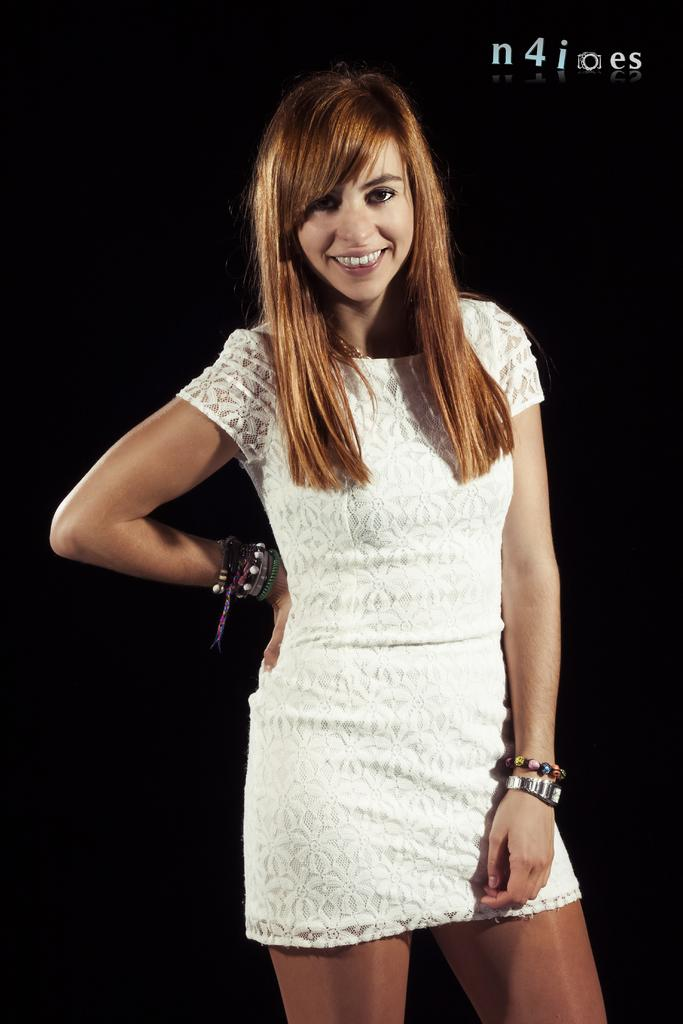What is the main subject of the image? There is a woman in the image. Can you describe the woman's attire? The woman is wearing a white dress. How is the woman described in the image? The woman is described as stunning. What type of waves can be seen crashing on the shore in the image? There are no waves or shore visible in the image; it features a woman wearing a white dress. Can you tell me how many mice are hiding under the woman's dress in the image? There are no mice present in the image; it features a woman wearing a white dress. 